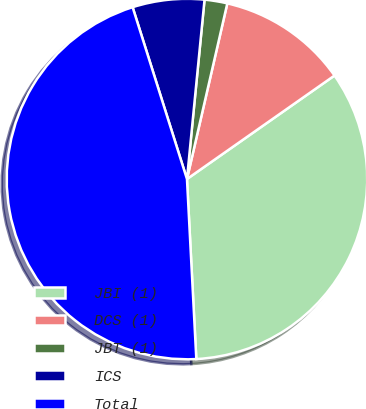<chart> <loc_0><loc_0><loc_500><loc_500><pie_chart><fcel>JBI (1)<fcel>DCS (1)<fcel>JBT (1)<fcel>ICS<fcel>Total<nl><fcel>33.91%<fcel>11.67%<fcel>2.04%<fcel>6.43%<fcel>45.95%<nl></chart> 